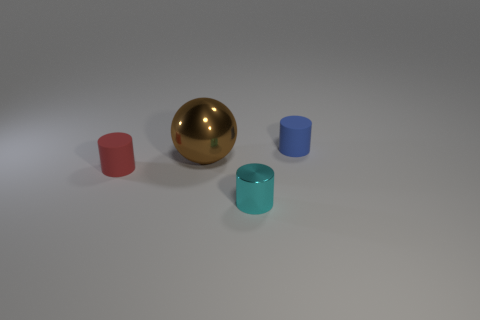What number of other objects are there of the same material as the tiny cyan cylinder?
Provide a succinct answer. 1. What number of things are either blue matte cylinders or tiny cylinders left of the big thing?
Offer a very short reply. 2. Is the number of brown metallic spheres less than the number of tiny matte things?
Make the answer very short. Yes. What is the color of the rubber cylinder on the left side of the small blue object that is behind the small matte object that is left of the blue object?
Keep it short and to the point. Red. Is the material of the tiny blue cylinder the same as the tiny cyan cylinder?
Your answer should be very brief. No. How many tiny red cylinders are behind the small blue matte thing?
Offer a very short reply. 0. The other matte thing that is the same shape as the red matte thing is what size?
Provide a short and direct response. Small. What number of red things are either large metallic objects or matte objects?
Your response must be concise. 1. There is a matte cylinder that is behind the big brown thing; what number of small cylinders are behind it?
Give a very brief answer. 0. What number of other things are there of the same shape as the blue thing?
Your answer should be very brief. 2. 